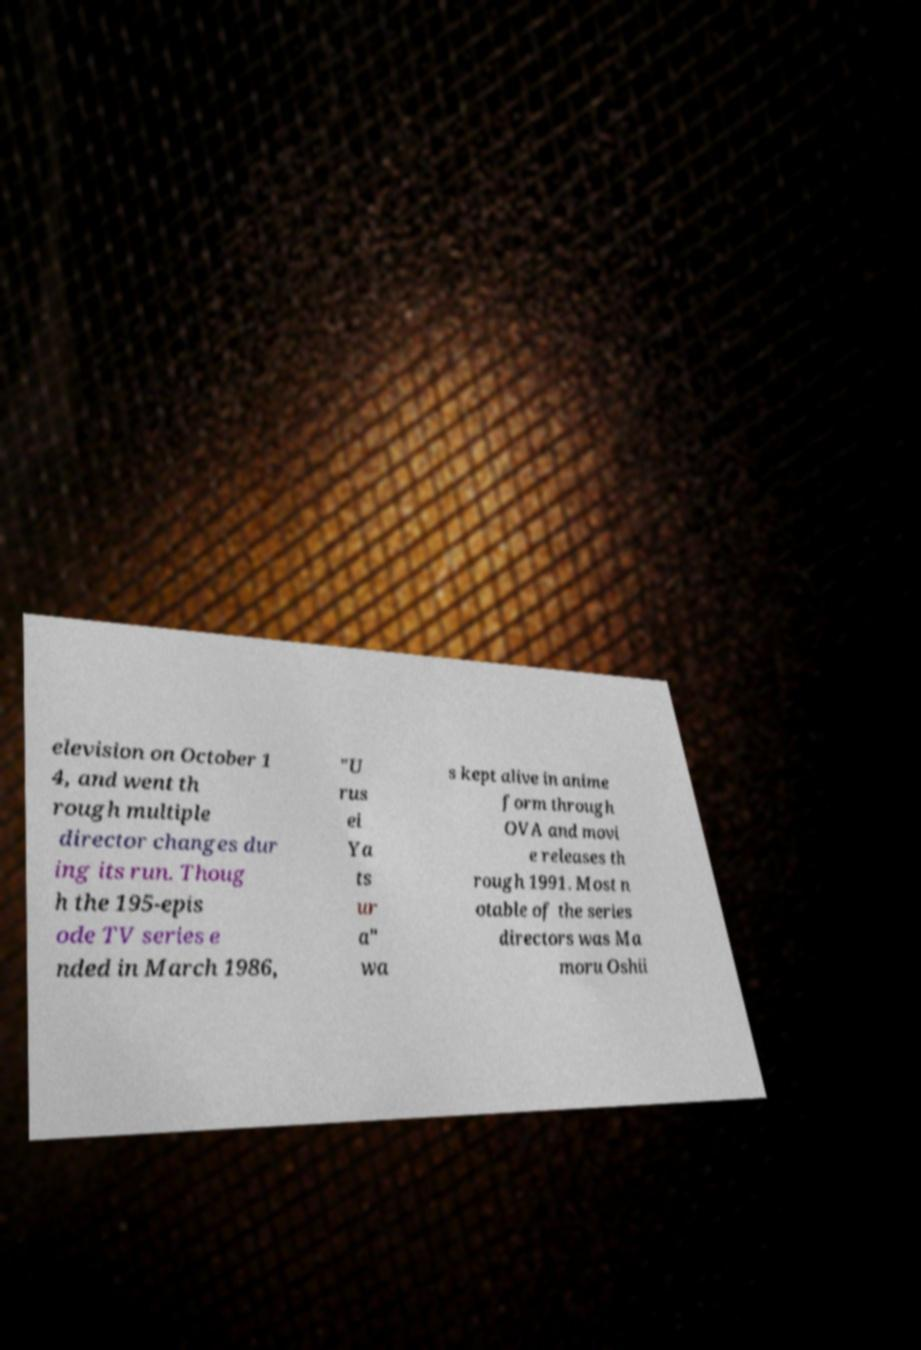What messages or text are displayed in this image? I need them in a readable, typed format. elevision on October 1 4, and went th rough multiple director changes dur ing its run. Thoug h the 195-epis ode TV series e nded in March 1986, "U rus ei Ya ts ur a" wa s kept alive in anime form through OVA and movi e releases th rough 1991. Most n otable of the series directors was Ma moru Oshii 